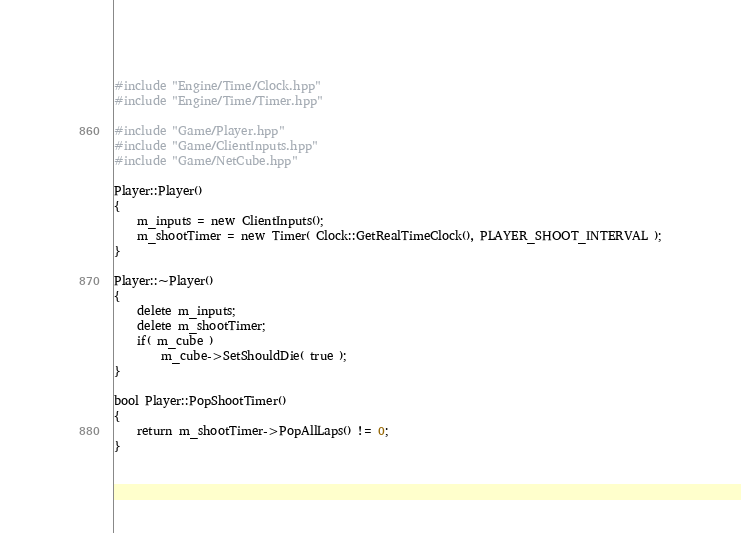Convert code to text. <code><loc_0><loc_0><loc_500><loc_500><_C++_>#include "Engine/Time/Clock.hpp"
#include "Engine/Time/Timer.hpp"

#include "Game/Player.hpp"
#include "Game/ClientInputs.hpp"
#include "Game/NetCube.hpp"

Player::Player()
{
    m_inputs = new ClientInputs();
    m_shootTimer = new Timer( Clock::GetRealTimeClock(), PLAYER_SHOOT_INTERVAL );
}

Player::~Player()
{
    delete m_inputs;
    delete m_shootTimer;
    if( m_cube )
        m_cube->SetShouldDie( true );
}

bool Player::PopShootTimer()
{
    return m_shootTimer->PopAllLaps() != 0;
}
</code> 